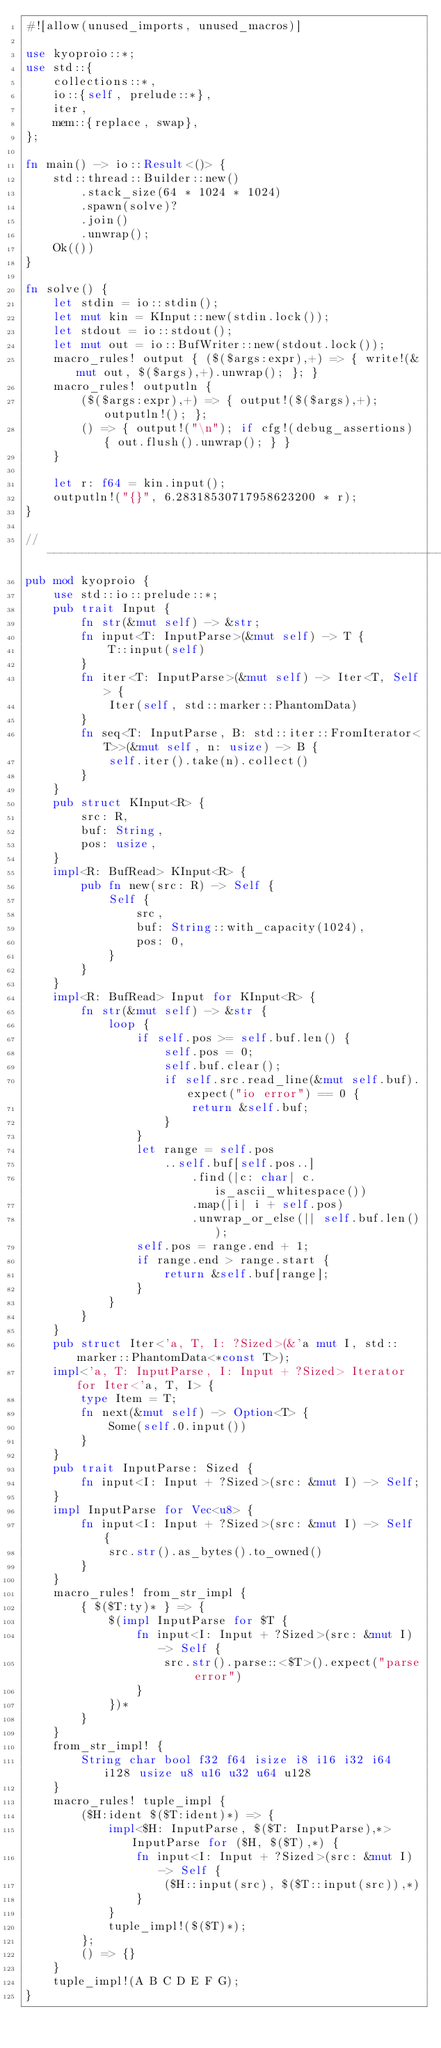Convert code to text. <code><loc_0><loc_0><loc_500><loc_500><_Rust_>#![allow(unused_imports, unused_macros)]

use kyoproio::*;
use std::{
    collections::*,
    io::{self, prelude::*},
    iter,
    mem::{replace, swap},
};

fn main() -> io::Result<()> {
    std::thread::Builder::new()
        .stack_size(64 * 1024 * 1024)
        .spawn(solve)?
        .join()
        .unwrap();
    Ok(())
}

fn solve() {
    let stdin = io::stdin();
    let mut kin = KInput::new(stdin.lock());
    let stdout = io::stdout();
    let mut out = io::BufWriter::new(stdout.lock());
    macro_rules! output { ($($args:expr),+) => { write!(&mut out, $($args),+).unwrap(); }; }
    macro_rules! outputln {
        ($($args:expr),+) => { output!($($args),+); outputln!(); };
        () => { output!("\n"); if cfg!(debug_assertions) { out.flush().unwrap(); } }
    }

    let r: f64 = kin.input();
    outputln!("{}", 6.28318530717958623200 * r);
}

// -----------------------------------------------------------------------------
pub mod kyoproio {
    use std::io::prelude::*;
    pub trait Input {
        fn str(&mut self) -> &str;
        fn input<T: InputParse>(&mut self) -> T {
            T::input(self)
        }
        fn iter<T: InputParse>(&mut self) -> Iter<T, Self> {
            Iter(self, std::marker::PhantomData)
        }
        fn seq<T: InputParse, B: std::iter::FromIterator<T>>(&mut self, n: usize) -> B {
            self.iter().take(n).collect()
        }
    }
    pub struct KInput<R> {
        src: R,
        buf: String,
        pos: usize,
    }
    impl<R: BufRead> KInput<R> {
        pub fn new(src: R) -> Self {
            Self {
                src,
                buf: String::with_capacity(1024),
                pos: 0,
            }
        }
    }
    impl<R: BufRead> Input for KInput<R> {
        fn str(&mut self) -> &str {
            loop {
                if self.pos >= self.buf.len() {
                    self.pos = 0;
                    self.buf.clear();
                    if self.src.read_line(&mut self.buf).expect("io error") == 0 {
                        return &self.buf;
                    }
                }
                let range = self.pos
                    ..self.buf[self.pos..]
                        .find(|c: char| c.is_ascii_whitespace())
                        .map(|i| i + self.pos)
                        .unwrap_or_else(|| self.buf.len());
                self.pos = range.end + 1;
                if range.end > range.start {
                    return &self.buf[range];
                }
            }
        }
    }
    pub struct Iter<'a, T, I: ?Sized>(&'a mut I, std::marker::PhantomData<*const T>);
    impl<'a, T: InputParse, I: Input + ?Sized> Iterator for Iter<'a, T, I> {
        type Item = T;
        fn next(&mut self) -> Option<T> {
            Some(self.0.input())
        }
    }
    pub trait InputParse: Sized {
        fn input<I: Input + ?Sized>(src: &mut I) -> Self;
    }
    impl InputParse for Vec<u8> {
        fn input<I: Input + ?Sized>(src: &mut I) -> Self {
            src.str().as_bytes().to_owned()
        }
    }
    macro_rules! from_str_impl {
        { $($T:ty)* } => {
            $(impl InputParse for $T {
                fn input<I: Input + ?Sized>(src: &mut I) -> Self {
                    src.str().parse::<$T>().expect("parse error")
                }
            })*
        }
    }
    from_str_impl! {
        String char bool f32 f64 isize i8 i16 i32 i64 i128 usize u8 u16 u32 u64 u128
    }
    macro_rules! tuple_impl {
        ($H:ident $($T:ident)*) => {
            impl<$H: InputParse, $($T: InputParse),*> InputParse for ($H, $($T),*) {
                fn input<I: Input + ?Sized>(src: &mut I) -> Self {
                    ($H::input(src), $($T::input(src)),*)
                }
            }
            tuple_impl!($($T)*);
        };
        () => {}
    }
    tuple_impl!(A B C D E F G);
}
</code> 